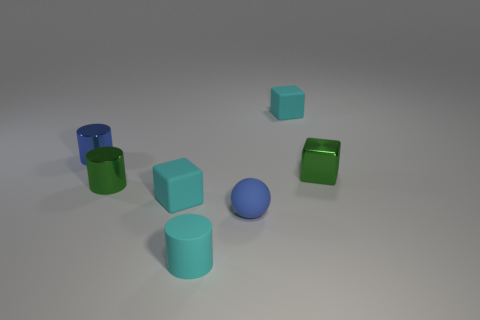What number of other objects are there of the same size as the green cylinder?
Offer a very short reply. 6. What number of rubber things are either small things or balls?
Offer a terse response. 4. There is a cyan thing that is on the left side of the small matte cylinder; is it the same shape as the green shiny thing left of the cyan matte cylinder?
Make the answer very short. No. What color is the small thing that is both behind the metal cube and on the left side of the tiny blue rubber sphere?
Offer a very short reply. Blue. There is a matte block to the left of the cyan matte cylinder; is its size the same as the cyan rubber cube behind the small blue cylinder?
Provide a short and direct response. Yes. How many spheres have the same color as the matte cylinder?
Ensure brevity in your answer.  0. How many small things are green metallic cubes or cyan objects?
Make the answer very short. 4. Do the tiny cyan thing behind the blue metal cylinder and the small blue sphere have the same material?
Make the answer very short. Yes. There is a tiny matte block that is behind the tiny blue metal cylinder; what is its color?
Give a very brief answer. Cyan. Is there a green metal cube of the same size as the rubber sphere?
Give a very brief answer. Yes. 